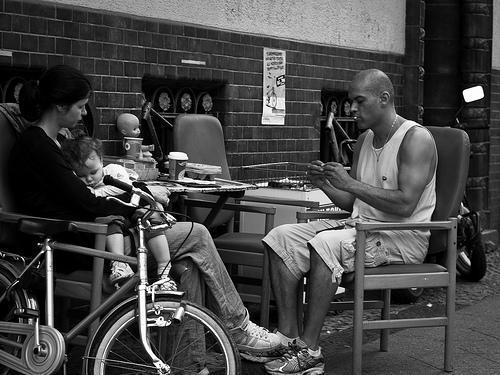How many babies are there?
Give a very brief answer. 1. 